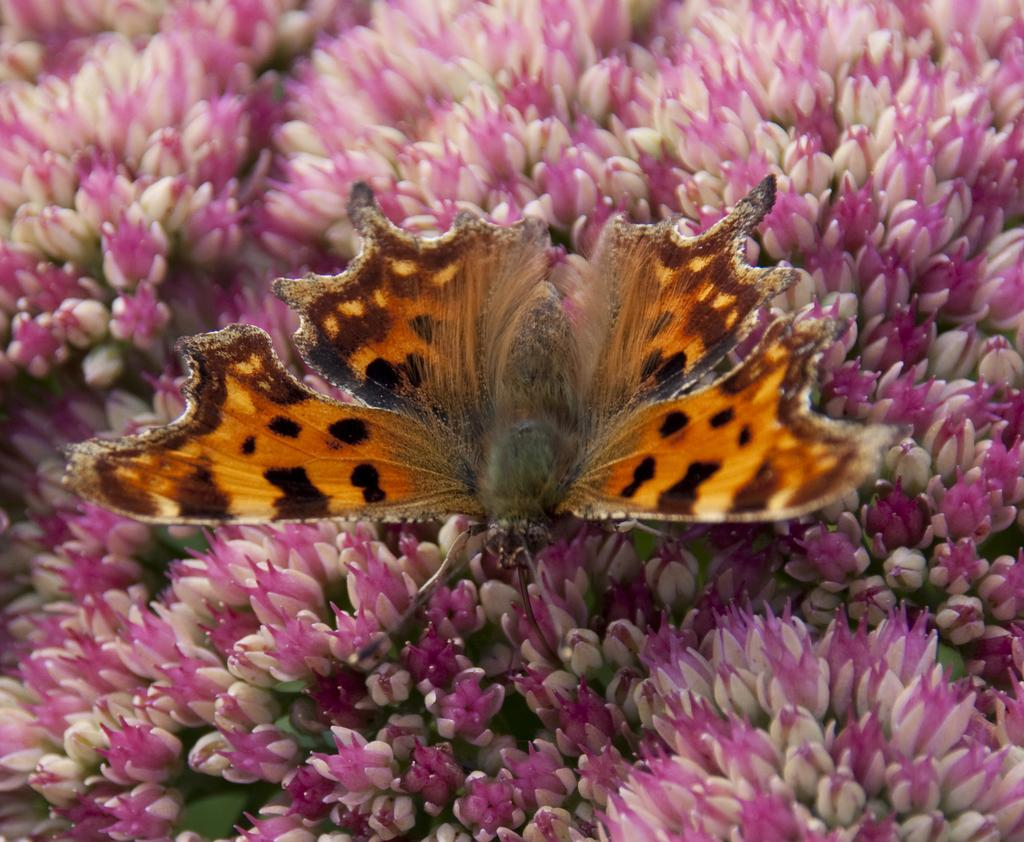What is the main subject of the image? There is a butterfly in the image. Where is the butterfly located in the image? The butterfly is on flowers. What type of honey is the butterfly collecting from the flowers in the image? There is no honey present in the image, and the butterfly is not collecting anything from the flowers. 